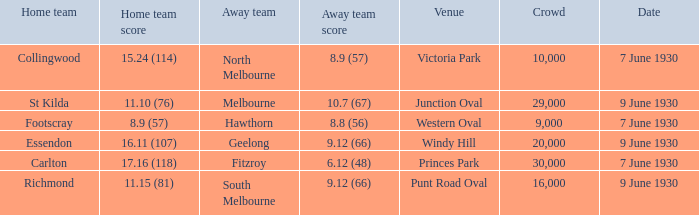What is the average crowd to watch Hawthorn as the away team? 9000.0. 